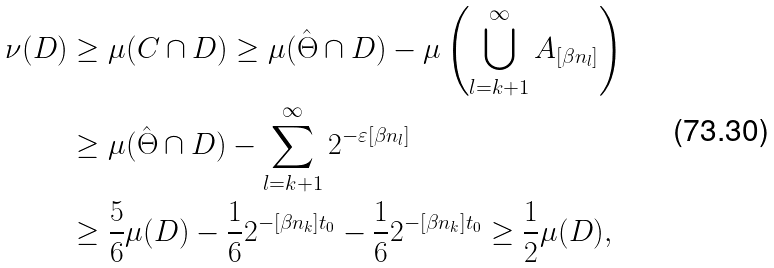<formula> <loc_0><loc_0><loc_500><loc_500>\nu ( D ) & \geq \mu ( C \cap D ) \geq \mu ( \hat { \Theta } \cap D ) - \mu \left ( \bigcup _ { l = k + 1 } ^ { \infty } A _ { [ \beta n _ { l } ] } \right ) \\ & \geq \mu ( \hat { \Theta } \cap D ) - \sum _ { l = k + 1 } ^ { \infty } 2 ^ { - \varepsilon [ \beta n _ { l } ] } \\ & \geq \frac { 5 } { 6 } \mu ( D ) - \frac { 1 } { 6 } 2 ^ { - [ \beta n _ { k } ] t _ { 0 } } - \frac { 1 } { 6 } 2 ^ { - [ \beta n _ { k } ] t _ { 0 } } \geq \frac { 1 } { 2 } \mu ( D ) ,</formula> 